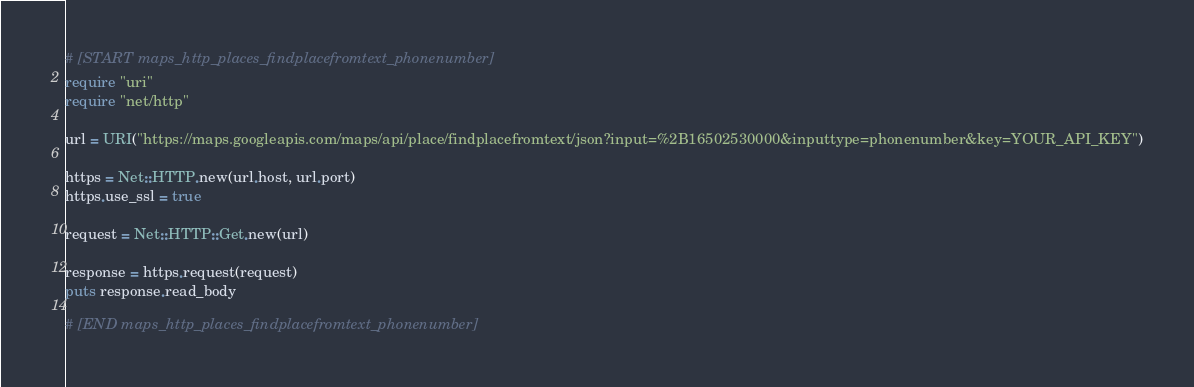Convert code to text. <code><loc_0><loc_0><loc_500><loc_500><_Ruby_># [START maps_http_places_findplacefromtext_phonenumber]
require "uri"
require "net/http"

url = URI("https://maps.googleapis.com/maps/api/place/findplacefromtext/json?input=%2B16502530000&inputtype=phonenumber&key=YOUR_API_KEY")

https = Net::HTTP.new(url.host, url.port)
https.use_ssl = true

request = Net::HTTP::Get.new(url)

response = https.request(request)
puts response.read_body

# [END maps_http_places_findplacefromtext_phonenumber]</code> 